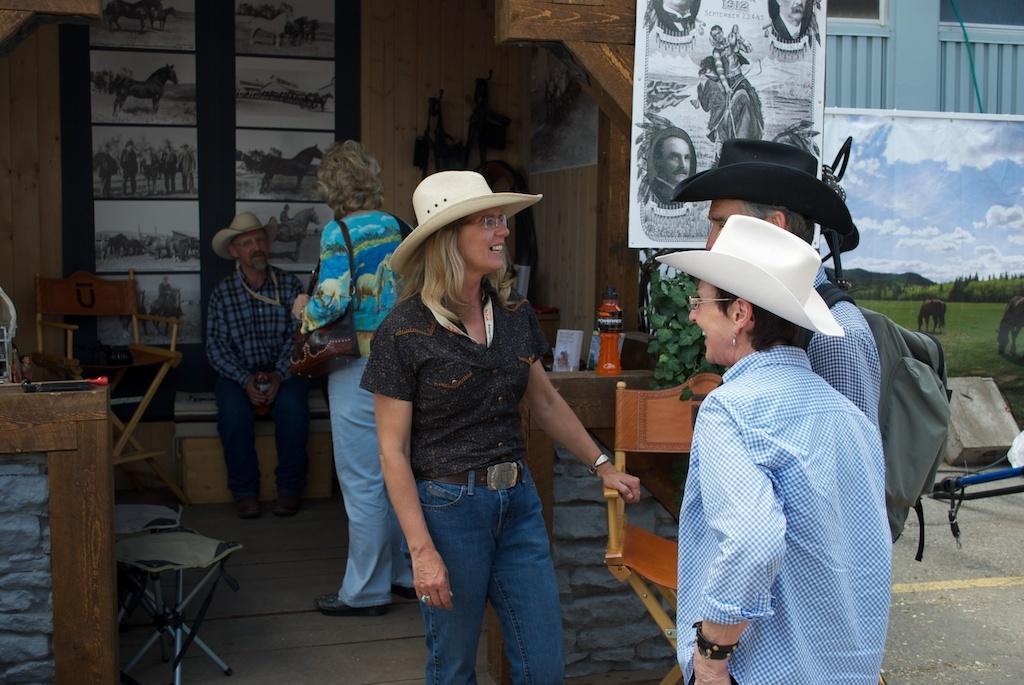In one or two sentences, can you explain what this image depicts? In this image there are group of persons sitting and standing and in the front there are persons standing and smiling. In the background there are paintings and there is a plant. On the left side there is a chair and there is a wooden stand and there are stools. On the right side there is the painting board and there is an object which is blue and black in colour. 